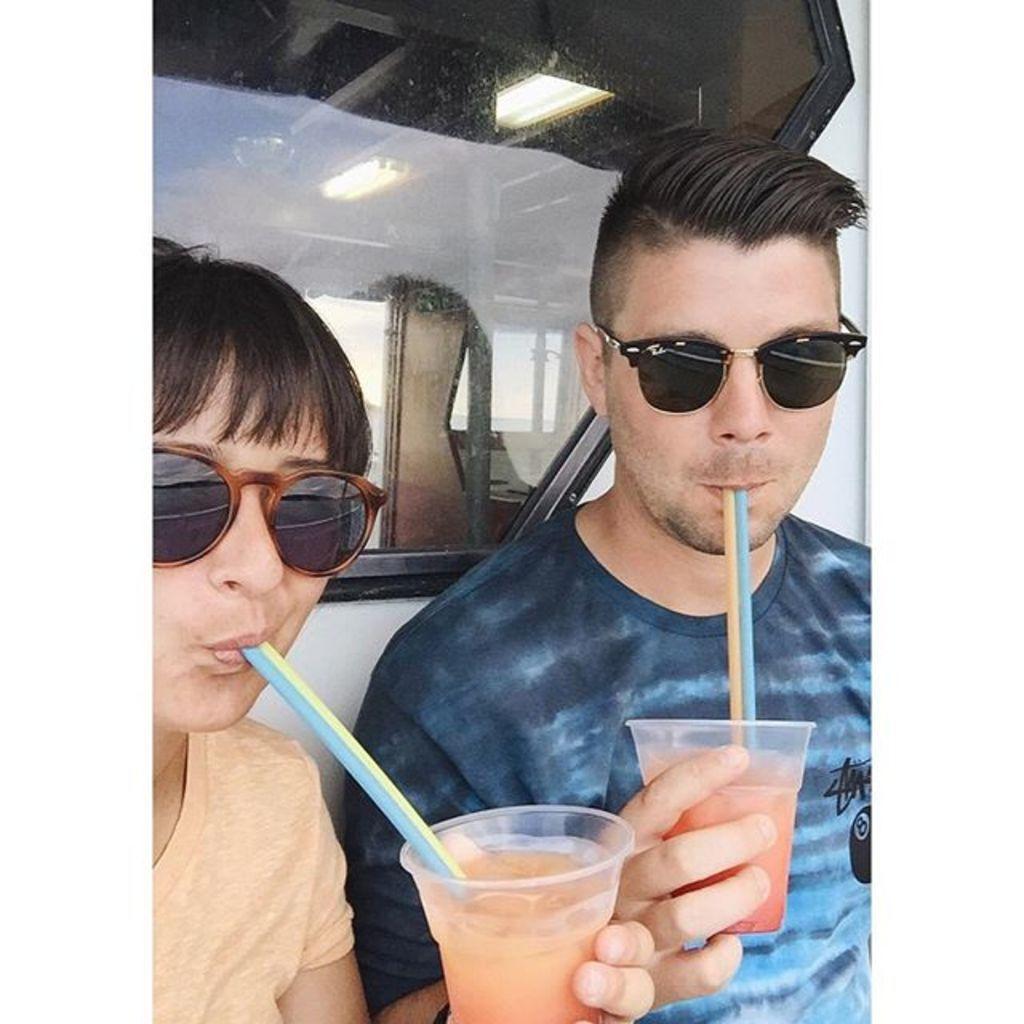How would you summarize this image in a sentence or two? In this picture there are two persons wearing goggles are holding a glass of juice in their hands and drinking it and there is a glass behind them. 